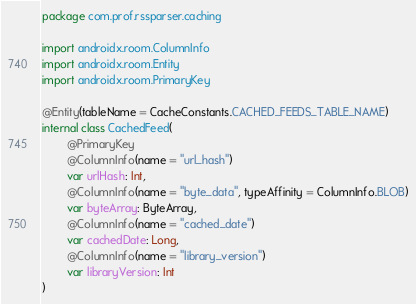Convert code to text. <code><loc_0><loc_0><loc_500><loc_500><_Kotlin_>package com.prof.rssparser.caching

import androidx.room.ColumnInfo
import androidx.room.Entity
import androidx.room.PrimaryKey

@Entity(tableName = CacheConstants.CACHED_FEEDS_TABLE_NAME)
internal class CachedFeed(
        @PrimaryKey
        @ColumnInfo(name = "url_hash")
        var urlHash: Int,
        @ColumnInfo(name = "byte_data", typeAffinity = ColumnInfo.BLOB)
        var byteArray: ByteArray,
        @ColumnInfo(name = "cached_date")
        var cachedDate: Long,
        @ColumnInfo(name = "library_version")
        var libraryVersion: Int
)
</code> 